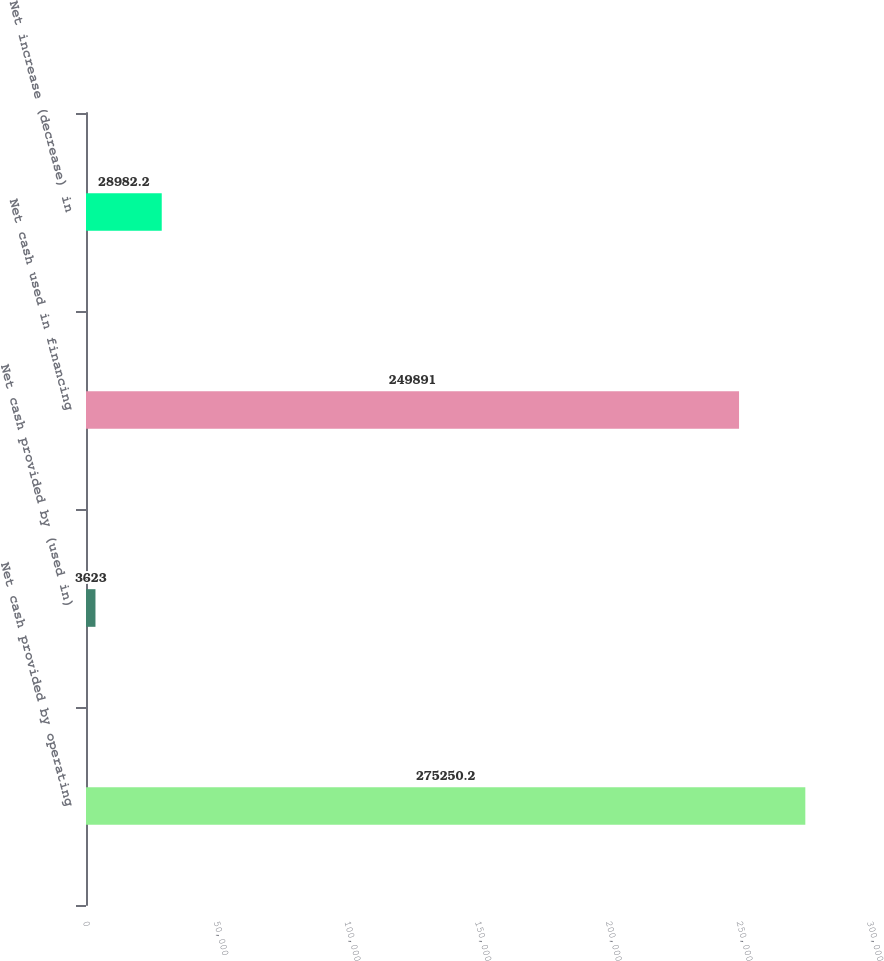Convert chart to OTSL. <chart><loc_0><loc_0><loc_500><loc_500><bar_chart><fcel>Net cash provided by operating<fcel>Net cash provided by (used in)<fcel>Net cash used in financing<fcel>Net increase (decrease) in<nl><fcel>275250<fcel>3623<fcel>249891<fcel>28982.2<nl></chart> 